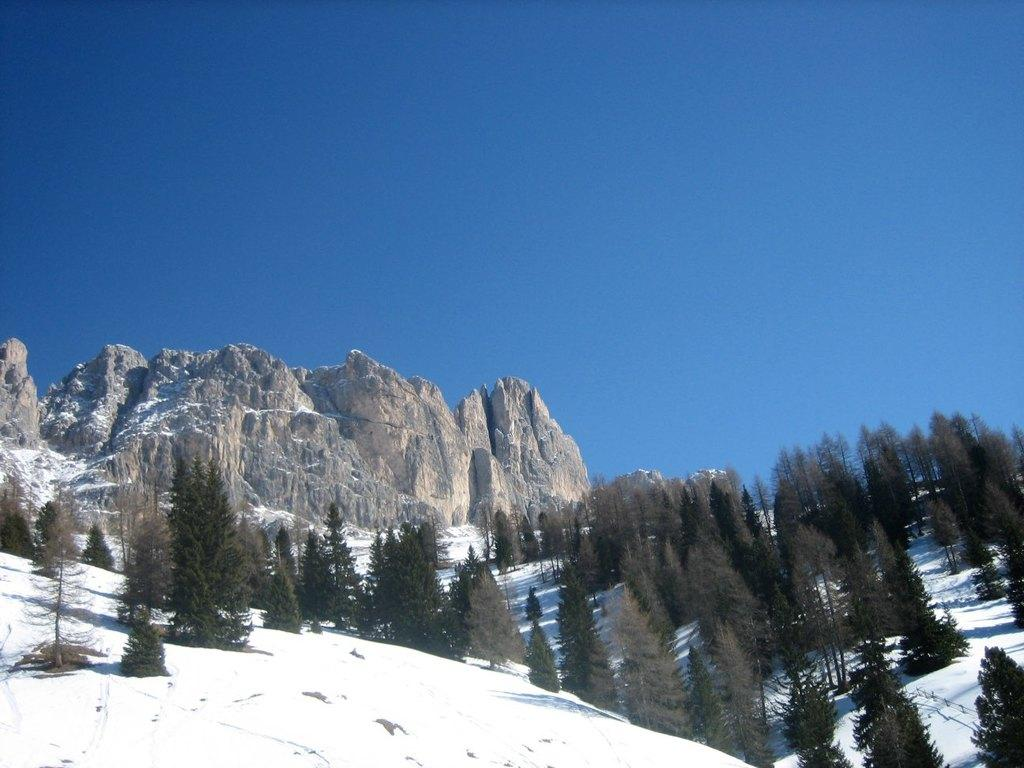What type of natural elements can be seen in the image? There are trees and hills in the image. What other objects can be found in the image? There are stones and ice in the image. What is visible in the background of the image? The sky is visible in the image. What type of holiday is being celebrated in the image? There is no indication of a holiday being celebrated in the image. How comfortable are the stones in the image? The comfort level of the stones cannot be determined from the image, as they are inanimate objects. 